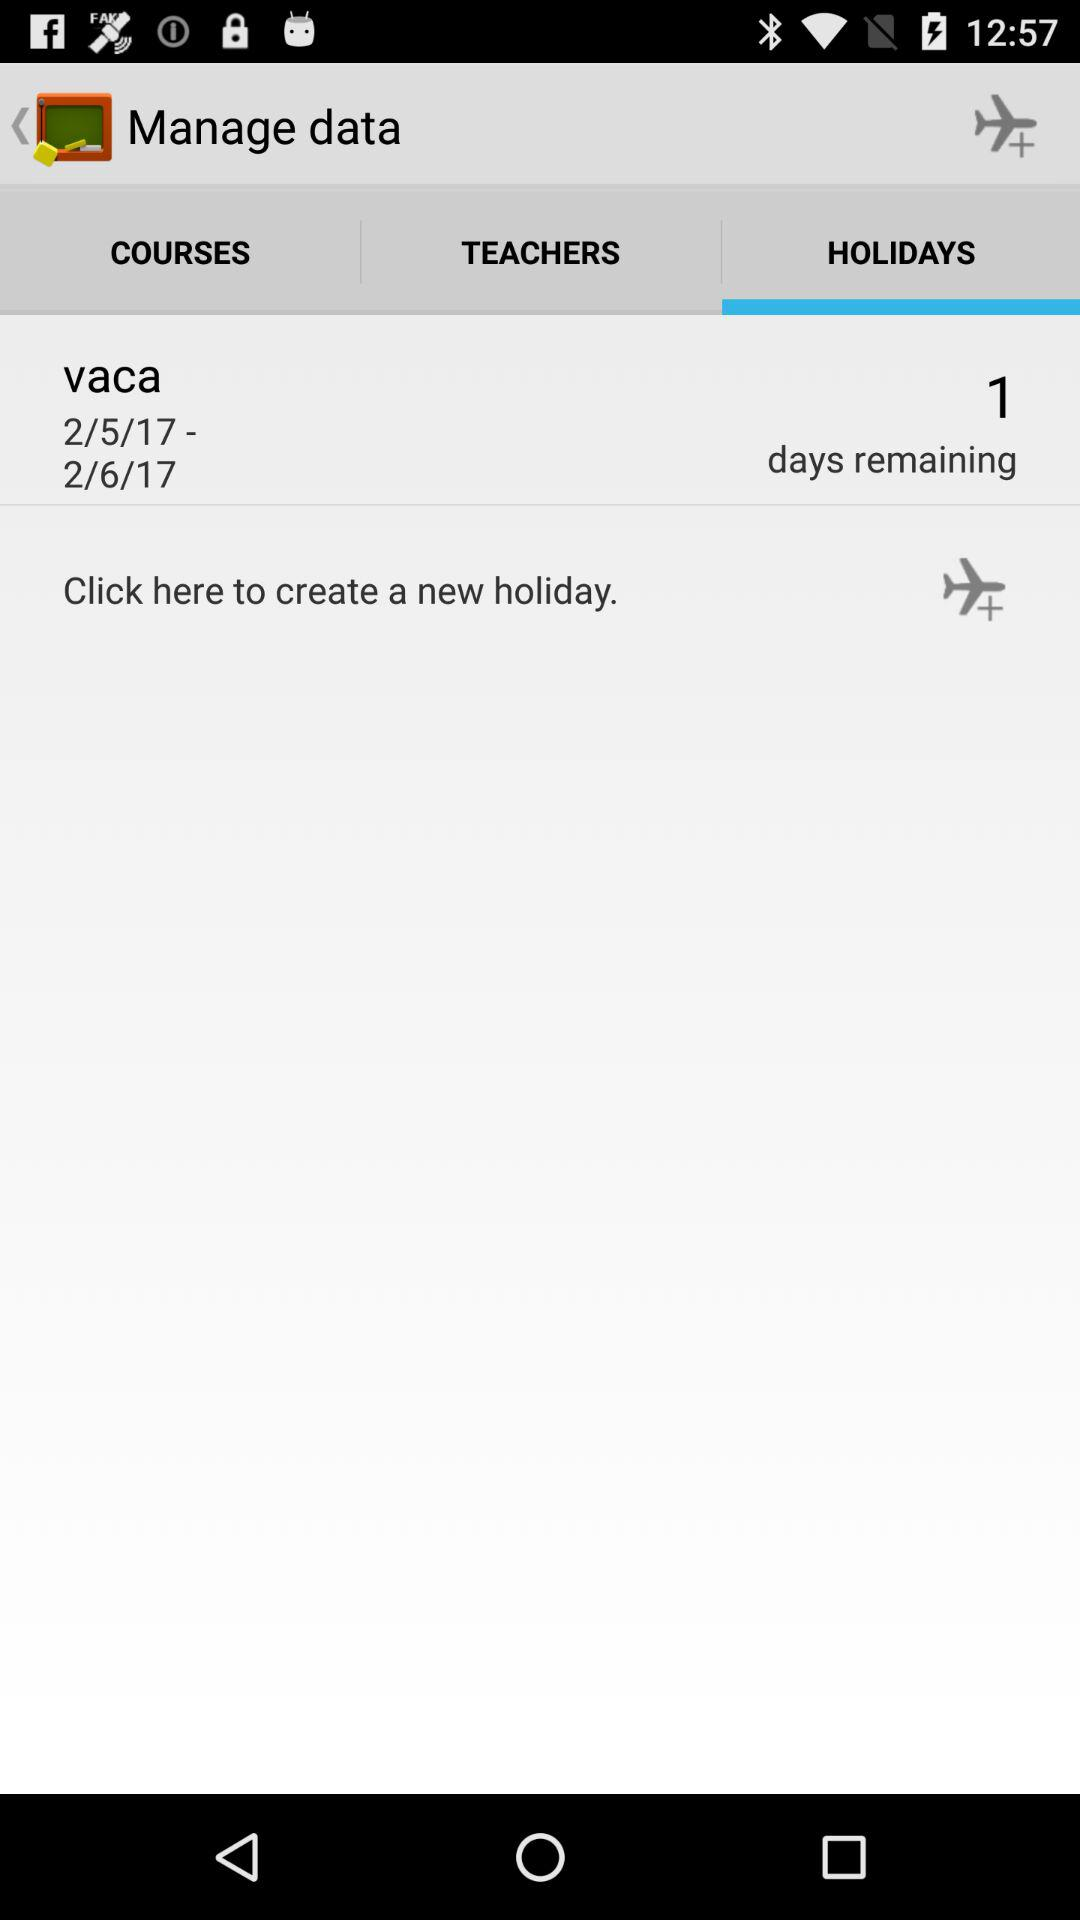How many more days are remaining until the holiday?
Answer the question using a single word or phrase. 1 